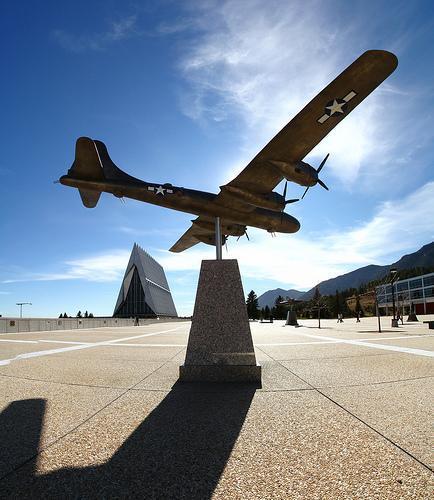How many stars are on the plane?
Give a very brief answer. 2. 